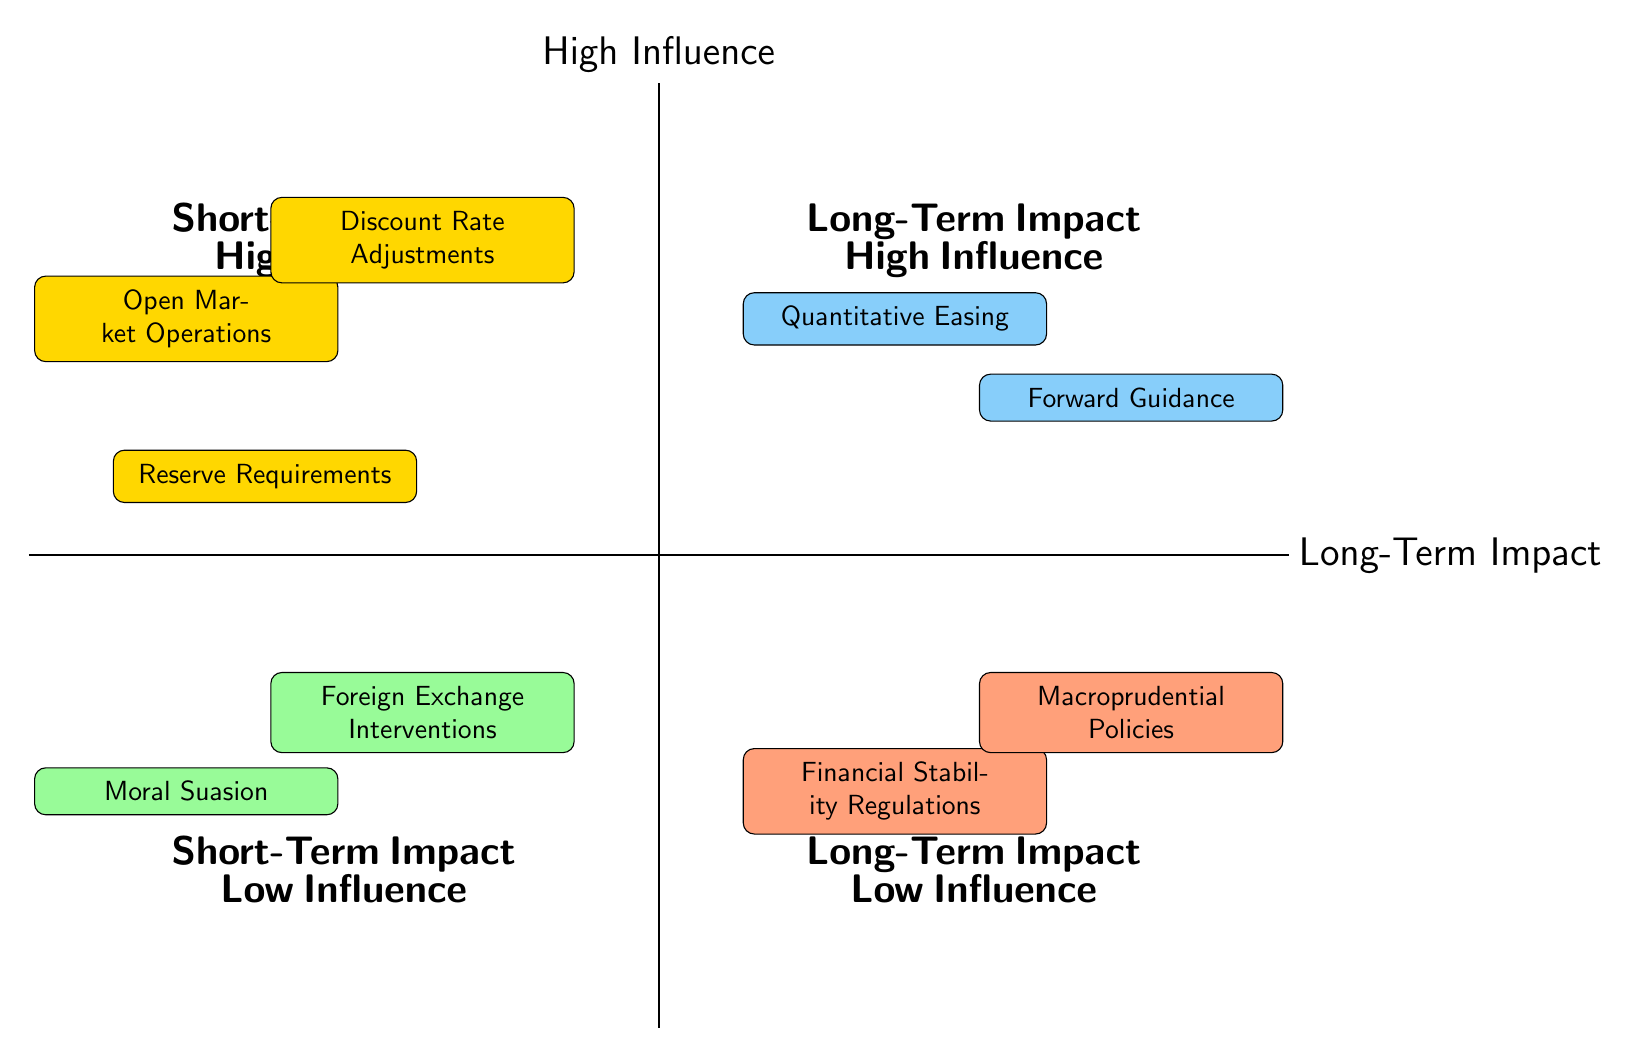What tools are in the Short-Term Impact and High Influence quadrant? According to the diagram, the tools located in the Short-Term Impact and High Influence quadrant include Open Market Operations, Discount Rate Adjustments, and Reserve Requirements.
Answer: Open Market Operations, Discount Rate Adjustments, Reserve Requirements How many tools affect the Long-Term Impact and Low Influence? By checking the Long-Term Impact and Low Influence quadrant, there are two tools present: Financial Stability Regulations and Macroprudential Policies.
Answer: 2 Which tool has a Long-Term Impact and is categorized as having High Influence? The quadrant labeled as Long-Term Impact and High Influence contains the tools Quantitative Easing and Forward Guidance. Therefore, one of those tools would be an answer; for instance, Quantitative Easing is one of the tools in that quadrant.
Answer: Quantitative Easing What is the description of Foreign Exchange Interventions? The diagram specifies that Foreign Exchange Interventions involve buying or selling foreign currencies to stabilize local currency value, mainly affecting short-term currency and inflation rates.
Answer: Buying or selling foreign currencies to stabilize local currency value, mainly affecting short-term currency and inflation rates Which quadrant contains tools that are both Low Influence and have a Short-Term Impact? The quadrant labeled as Short-Term Impact and Low Influence contains the tools Moral Suasion and Foreign Exchange Interventions.
Answer: Short-Term Impact and Low Influence How many tools fall into the Long-Term Impact and High Influence category? The diagram indicates two tools in the Long-Term Impact and High Influence quadrant, which are Quantitative Easing and Forward Guidance.
Answer: 2 What are the tools associated with Long-Term Impact and Low Influence? In the diagram, Financial Stability Regulations and Macroprudential Policies are identified as the tools that fall under Long-Term Impact and Low Influence.
Answer: Financial Stability Regulations, Macroprudential Policies What does the Reserve Requirements tool influence mainly? The diagram states that Reserve Requirements involve modifying the fraction of deposits that banks must hold in reserve, thus controlling the amount of money that banks can lend, primarily affecting short-term liquidity.
Answer: Short-term liquidity 